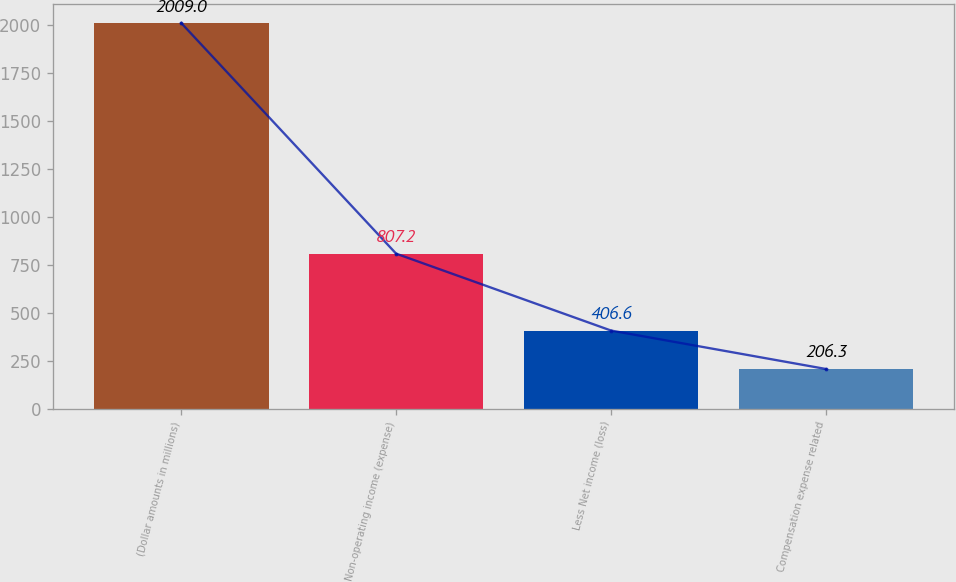Convert chart to OTSL. <chart><loc_0><loc_0><loc_500><loc_500><bar_chart><fcel>(Dollar amounts in millions)<fcel>Non-operating income (expense)<fcel>Less Net income (loss)<fcel>Compensation expense related<nl><fcel>2009<fcel>807.2<fcel>406.6<fcel>206.3<nl></chart> 